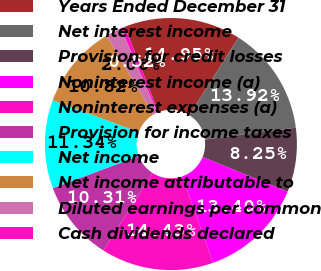<chart> <loc_0><loc_0><loc_500><loc_500><pie_chart><fcel>Years Ended December 31<fcel>Net interest income<fcel>Provision for credit losses<fcel>Noninterest income (a)<fcel>Noninterest expenses (a)<fcel>Provision for income taxes<fcel>Net income<fcel>Net income attributable to<fcel>Diluted earnings per common<fcel>Cash dividends declared<nl><fcel>14.95%<fcel>13.92%<fcel>8.25%<fcel>13.4%<fcel>14.43%<fcel>10.31%<fcel>11.34%<fcel>10.82%<fcel>2.06%<fcel>0.52%<nl></chart> 